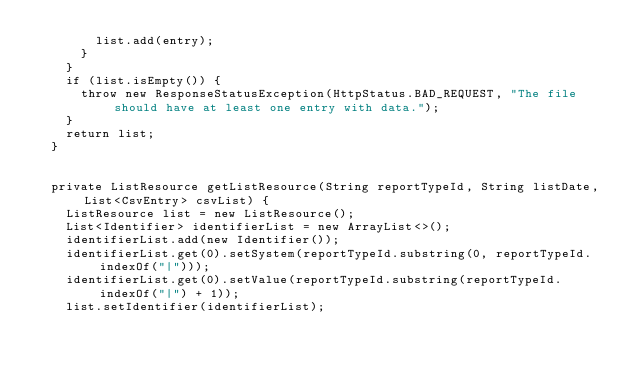Convert code to text. <code><loc_0><loc_0><loc_500><loc_500><_Java_>        list.add(entry);
      }
    }
    if (list.isEmpty()) {
      throw new ResponseStatusException(HttpStatus.BAD_REQUEST, "The file should have at least one entry with data.");
    }
    return list;
  }


  private ListResource getListResource(String reportTypeId, String listDate, List<CsvEntry> csvList) {
    ListResource list = new ListResource();
    List<Identifier> identifierList = new ArrayList<>();
    identifierList.add(new Identifier());
    identifierList.get(0).setSystem(reportTypeId.substring(0, reportTypeId.indexOf("|")));
    identifierList.get(0).setValue(reportTypeId.substring(reportTypeId.indexOf("|") + 1));
    list.setIdentifier(identifierList);</code> 